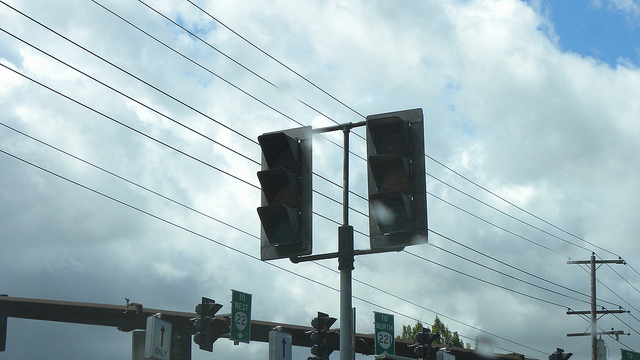Read and extract the text from this image. NEST 22 221 